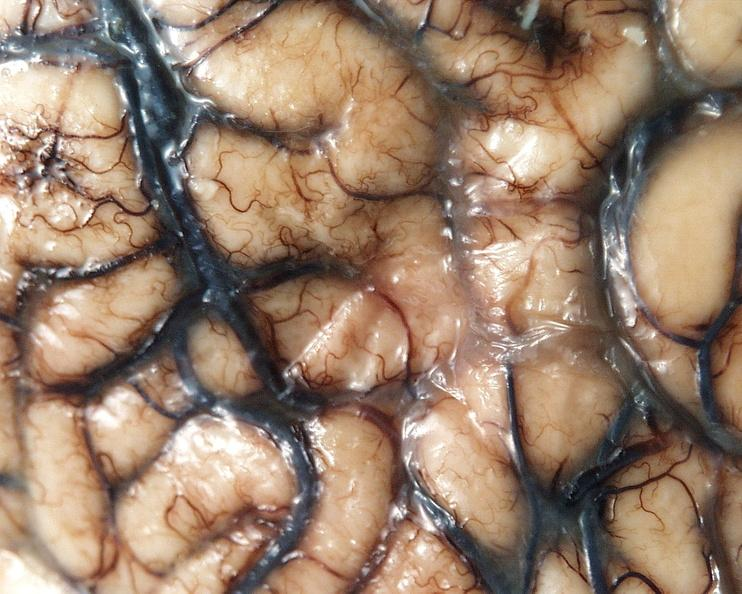does this image show brain, cryptococcal meningitis?
Answer the question using a single word or phrase. Yes 